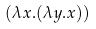<formula> <loc_0><loc_0><loc_500><loc_500>( \lambda x . ( \lambda y . x ) )</formula> 